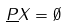<formula> <loc_0><loc_0><loc_500><loc_500>\underline { P } X = \emptyset</formula> 